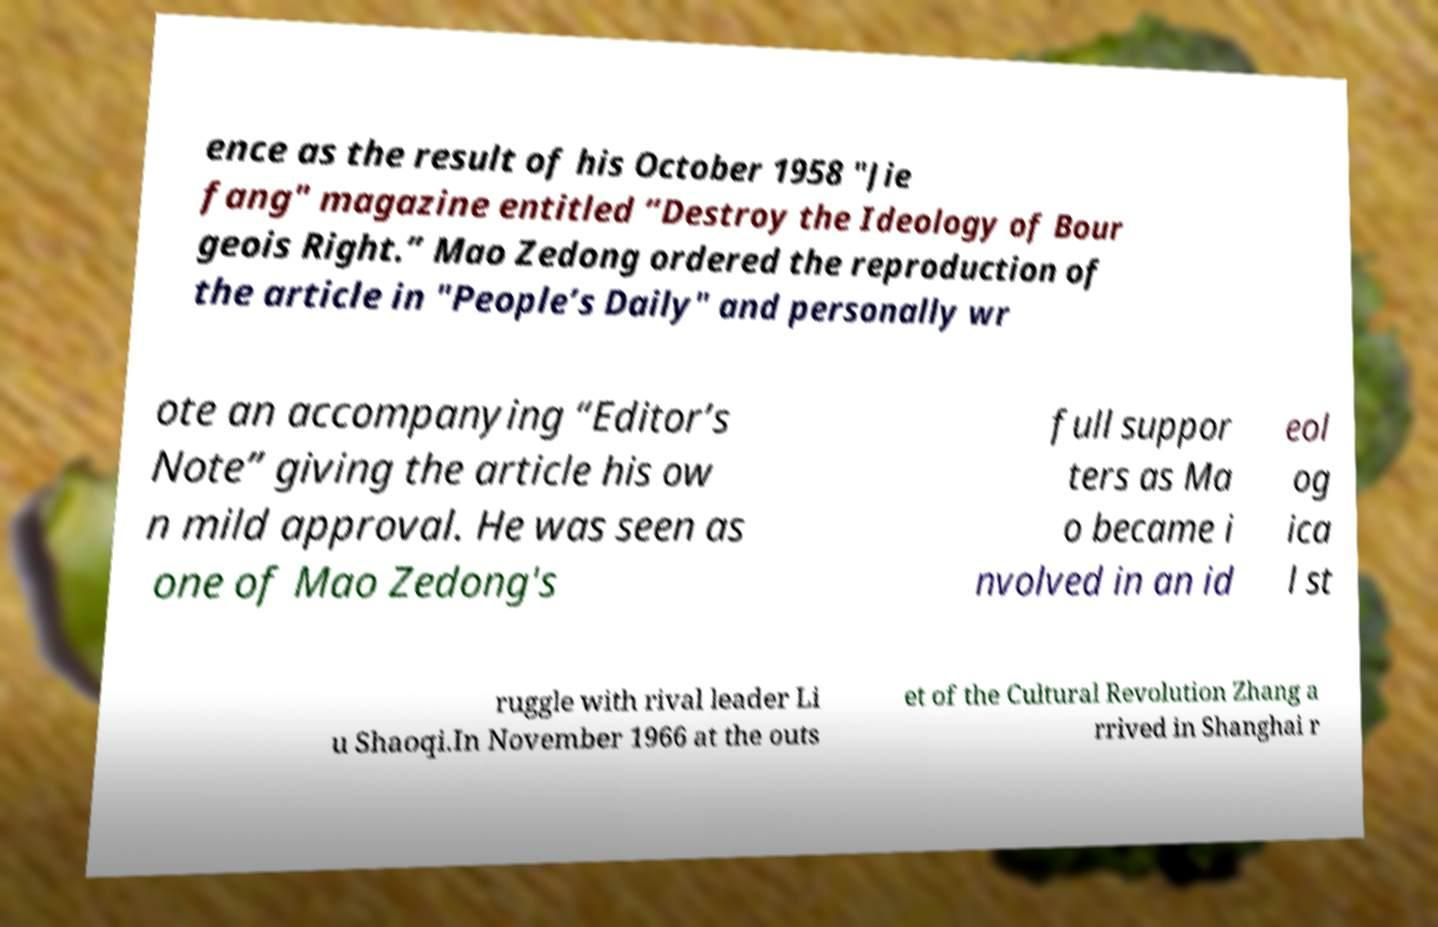For documentation purposes, I need the text within this image transcribed. Could you provide that? ence as the result of his October 1958 "Jie fang" magazine entitled “Destroy the Ideology of Bour geois Right.” Mao Zedong ordered the reproduction of the article in "People’s Daily" and personally wr ote an accompanying “Editor’s Note” giving the article his ow n mild approval. He was seen as one of Mao Zedong's full suppor ters as Ma o became i nvolved in an id eol og ica l st ruggle with rival leader Li u Shaoqi.In November 1966 at the outs et of the Cultural Revolution Zhang a rrived in Shanghai r 